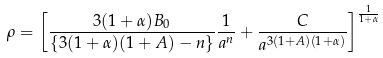<formula> <loc_0><loc_0><loc_500><loc_500>\rho = \left [ \frac { 3 ( 1 + \alpha ) B _ { 0 } } { \{ 3 ( 1 + \alpha ) ( 1 + A ) - n \} } \frac { 1 } { a ^ { n } } + \frac { C } { a ^ { 3 ( 1 + A ) ( 1 + \alpha ) } } \right ] ^ { \frac { 1 } { 1 + \alpha } }</formula> 